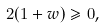<formula> <loc_0><loc_0><loc_500><loc_500>2 ( 1 + w ) \geqslant 0 ,</formula> 